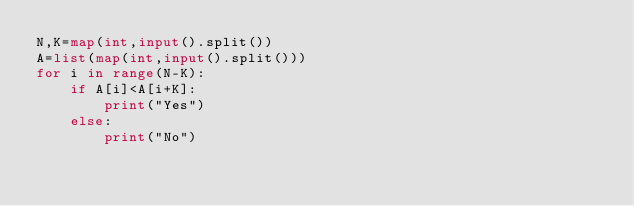<code> <loc_0><loc_0><loc_500><loc_500><_Python_>N,K=map(int,input().split())
A=list(map(int,input().split()))
for i in range(N-K):
    if A[i]<A[i+K]:
        print("Yes")
    else:
        print("No")</code> 